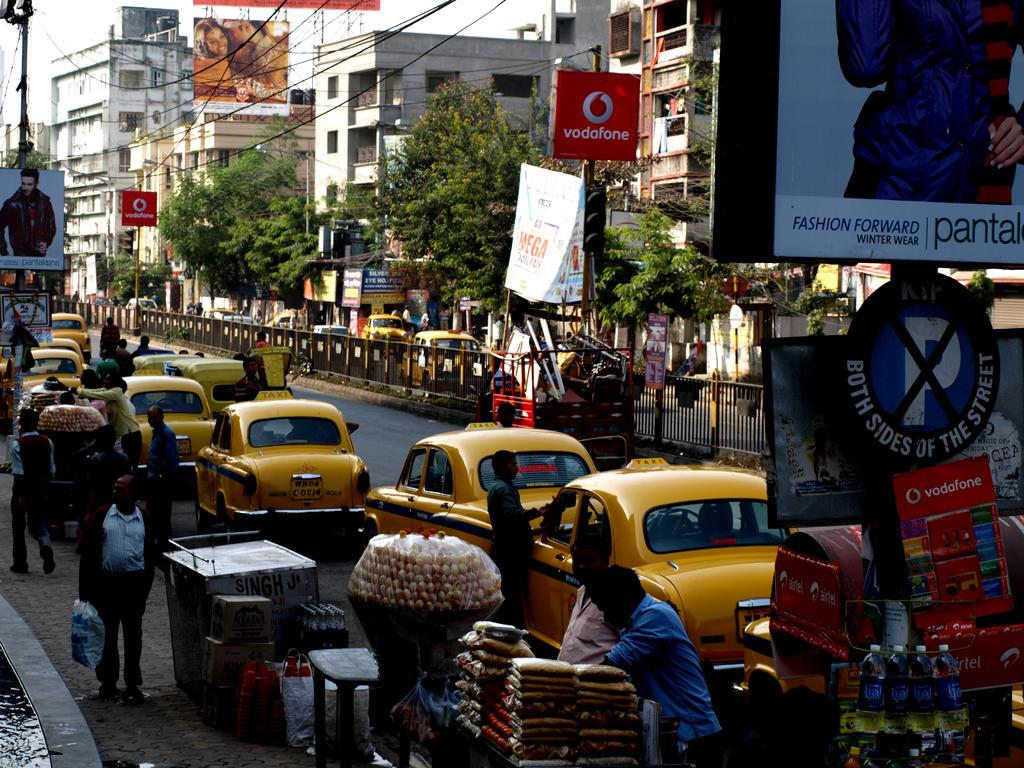<image>
Create a compact narrative representing the image presented. Several taxi cabs are bumper to bumper on the road, in a very busy city with red banners that say Vodafone. 